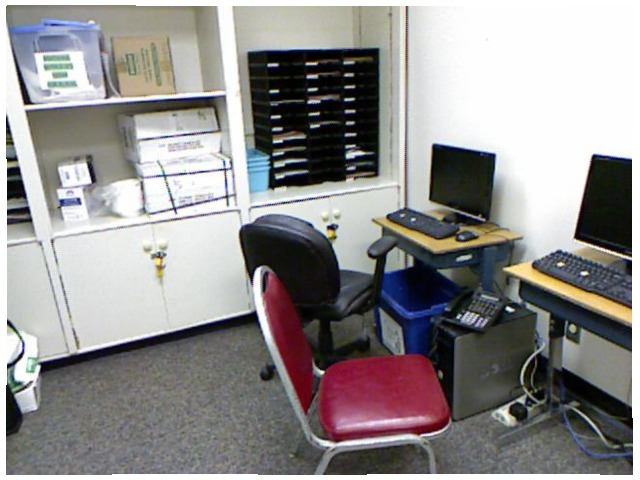<image>
Is the chair in front of the desk? No. The chair is not in front of the desk. The spatial positioning shows a different relationship between these objects. Where is the computer in relation to the chair? Is it on the chair? No. The computer is not positioned on the chair. They may be near each other, but the computer is not supported by or resting on top of the chair. Where is the cabinet in relation to the desk chair? Is it on the desk chair? No. The cabinet is not positioned on the desk chair. They may be near each other, but the cabinet is not supported by or resting on top of the desk chair. Where is the trash bin in relation to the desk? Is it under the desk? Yes. The trash bin is positioned underneath the desk, with the desk above it in the vertical space. Is the chair next to the desk? Yes. The chair is positioned adjacent to the desk, located nearby in the same general area. 